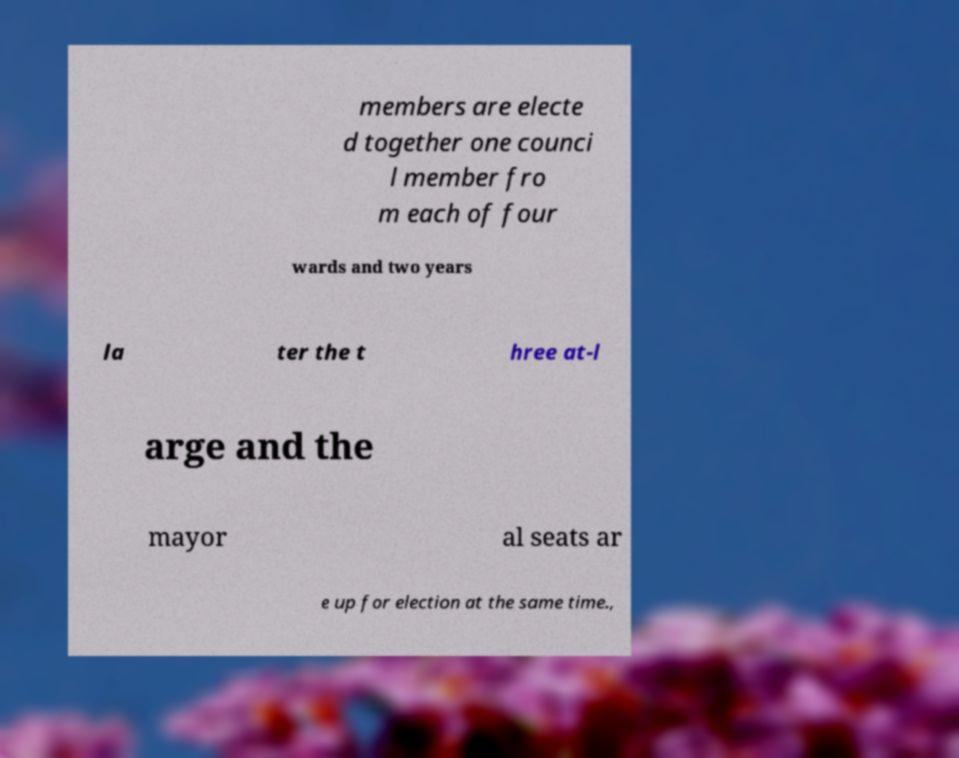Please identify and transcribe the text found in this image. members are electe d together one counci l member fro m each of four wards and two years la ter the t hree at-l arge and the mayor al seats ar e up for election at the same time., 